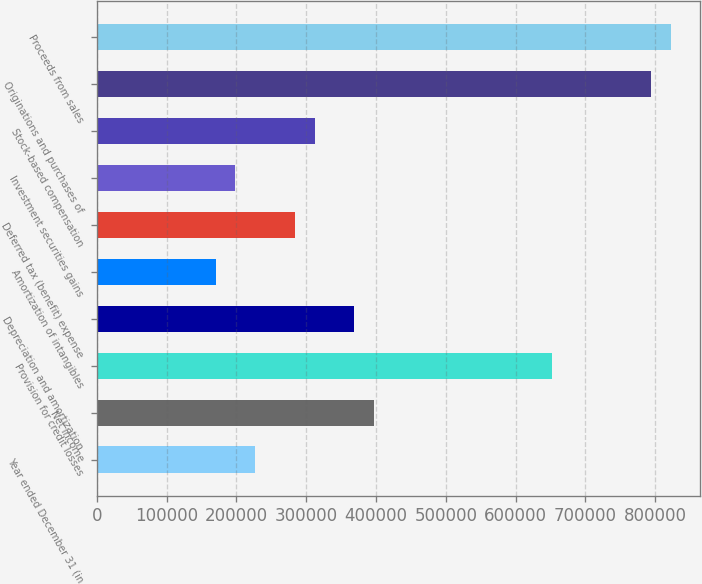<chart> <loc_0><loc_0><loc_500><loc_500><bar_chart><fcel>Year ended December 31 (in<fcel>Net income<fcel>Provision for credit losses<fcel>Depreciation and amortization<fcel>Amortization of intangibles<fcel>Deferred tax (benefit) expense<fcel>Investment securities gains<fcel>Stock-based compensation<fcel>Originations and purchases of<fcel>Proceeds from sales<nl><fcel>226939<fcel>397135<fcel>652430<fcel>368769<fcel>170207<fcel>283671<fcel>198573<fcel>312037<fcel>794261<fcel>822627<nl></chart> 